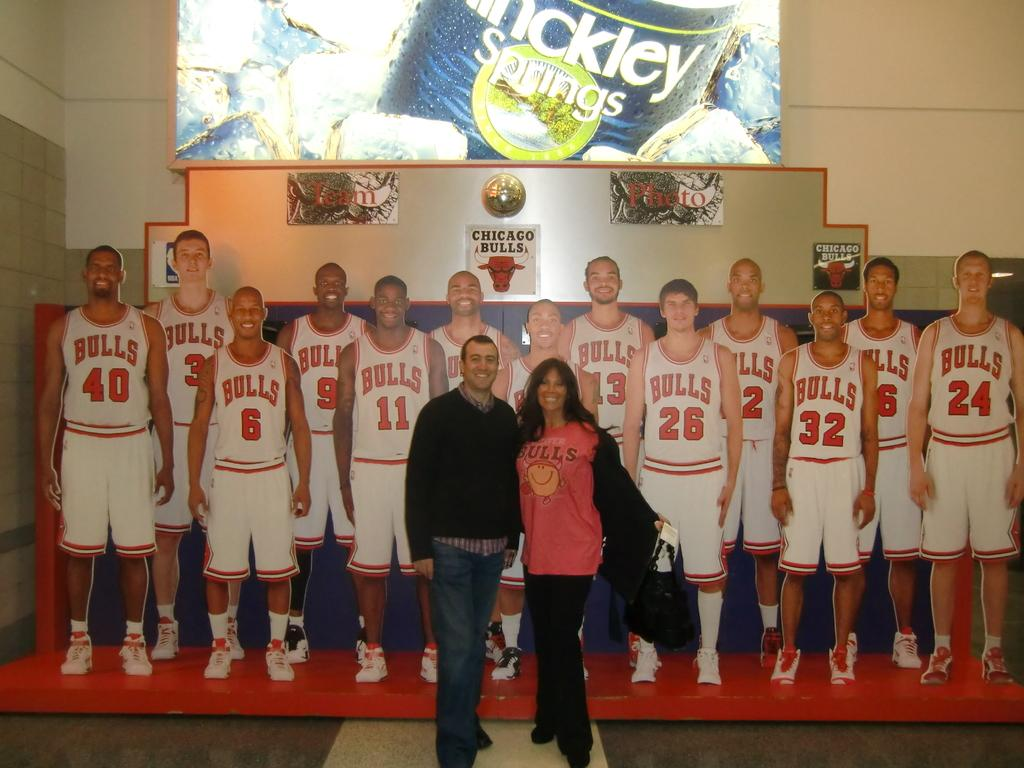Provide a one-sentence caption for the provided image. A couple takes a photo in front of a representation of the Chicago Bulls team. 